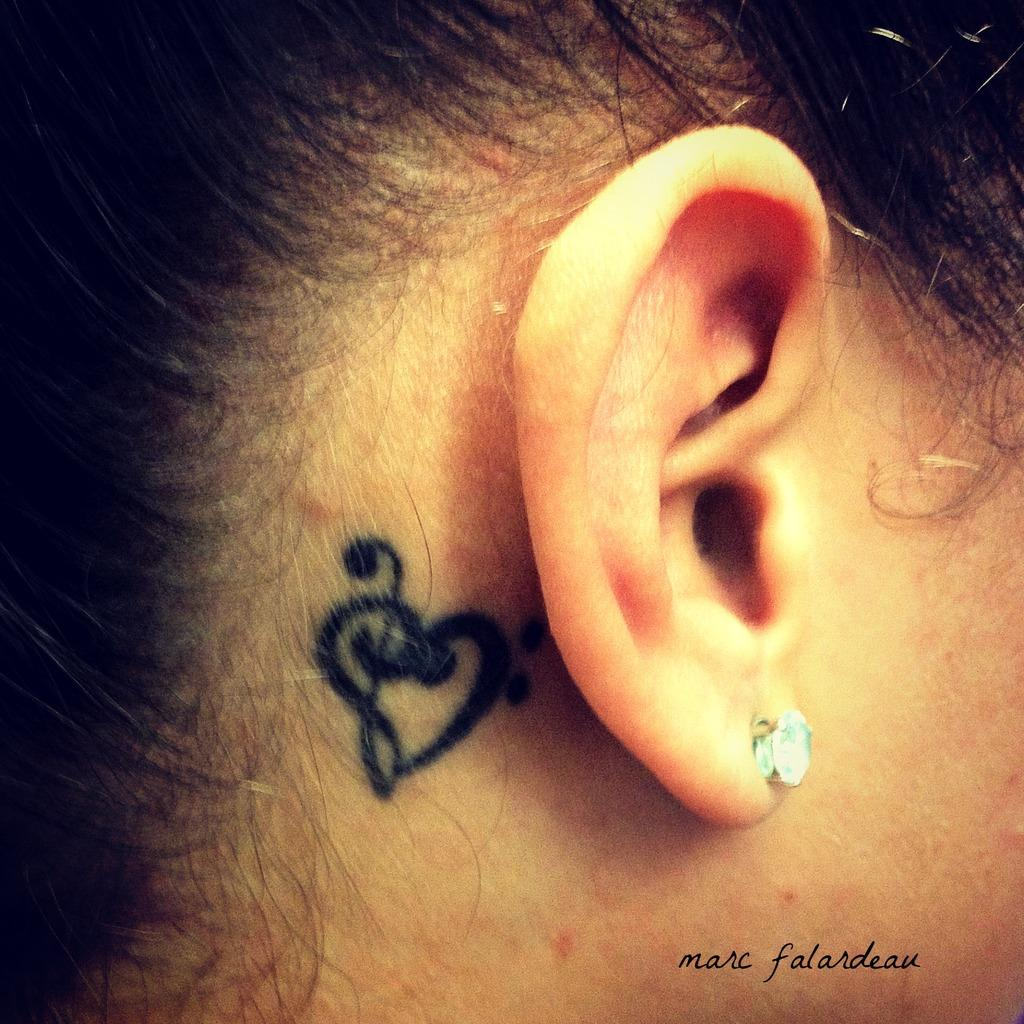What body part is visible in the image? There is a person's ear visible in the image. What accessory is the person wearing on their ear? The person is wearing an earring. What additional feature is present near the ear? There is a tattoo beside the ear. What can be found at the bottom of the image? There is text at the bottom of the image. How many friends are holding flowers in the image? There are no friends or flowers present in the image; it only features a person's ear, an earring, a tattoo, and text. 